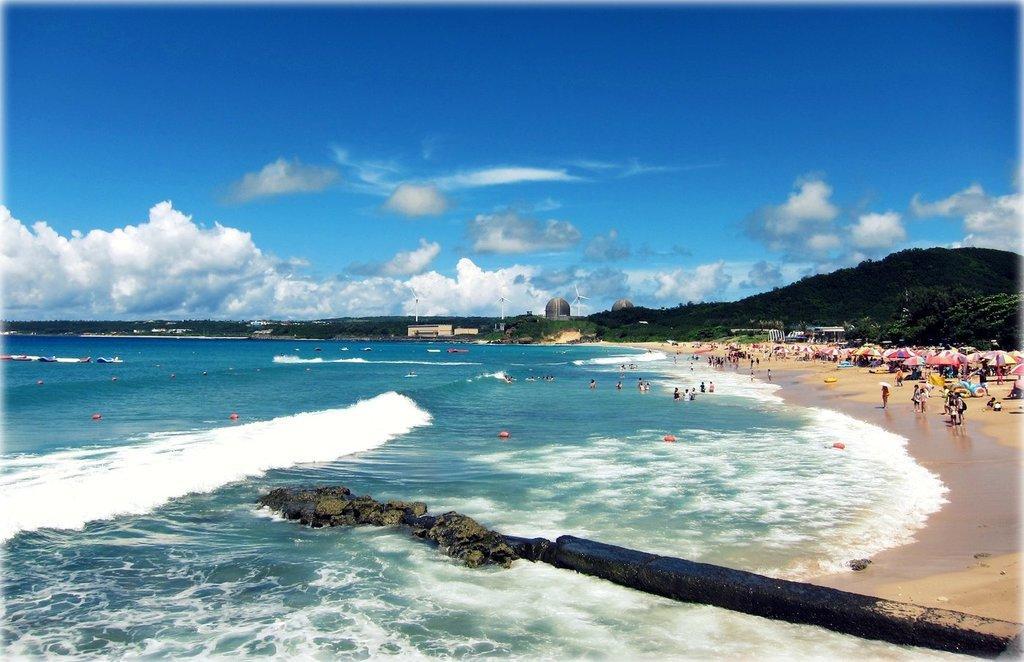Please provide a concise description of this image. In this image there are group of people in water, there are umbrellas, group of people , there are trees, buildings, wind mills, hills, and in the background there is sky. 